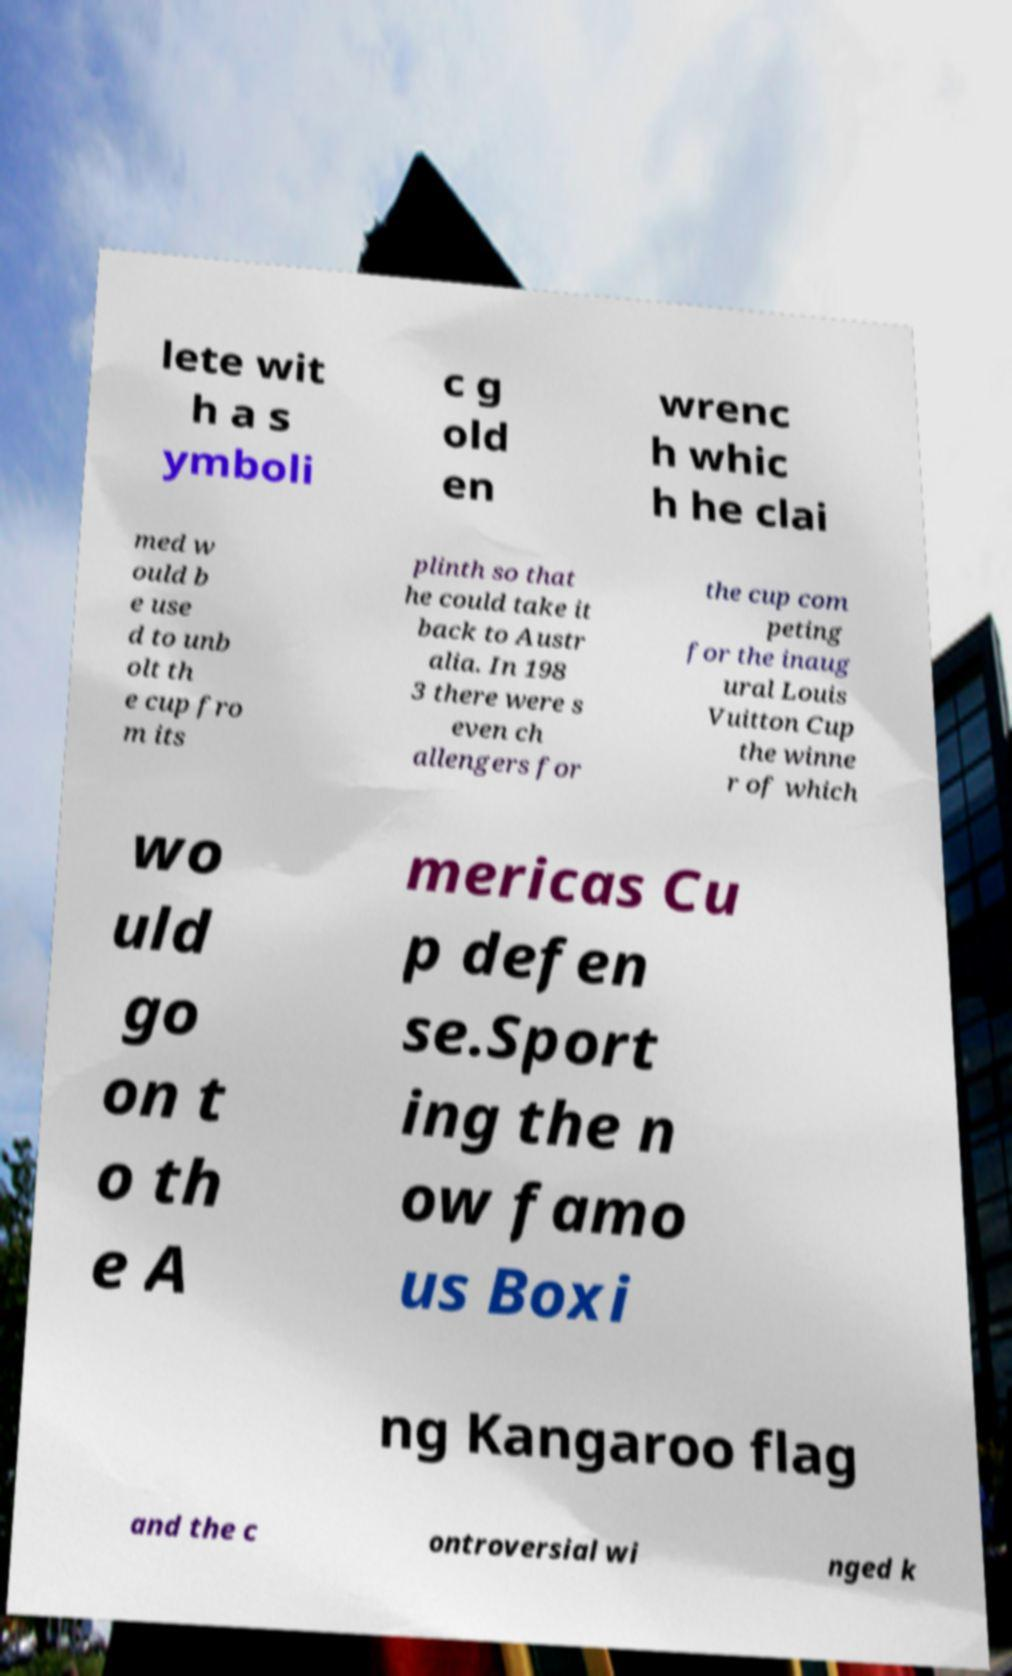Could you assist in decoding the text presented in this image and type it out clearly? lete wit h a s ymboli c g old en wrenc h whic h he clai med w ould b e use d to unb olt th e cup fro m its plinth so that he could take it back to Austr alia. In 198 3 there were s even ch allengers for the cup com peting for the inaug ural Louis Vuitton Cup the winne r of which wo uld go on t o th e A mericas Cu p defen se.Sport ing the n ow famo us Boxi ng Kangaroo flag and the c ontroversial wi nged k 